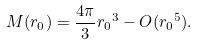<formula> <loc_0><loc_0><loc_500><loc_500>M ( r _ { 0 } ) = \frac { 4 \pi } { 3 } { r _ { 0 } } ^ { 3 } - O ( { r _ { 0 } } ^ { 5 } ) .</formula> 